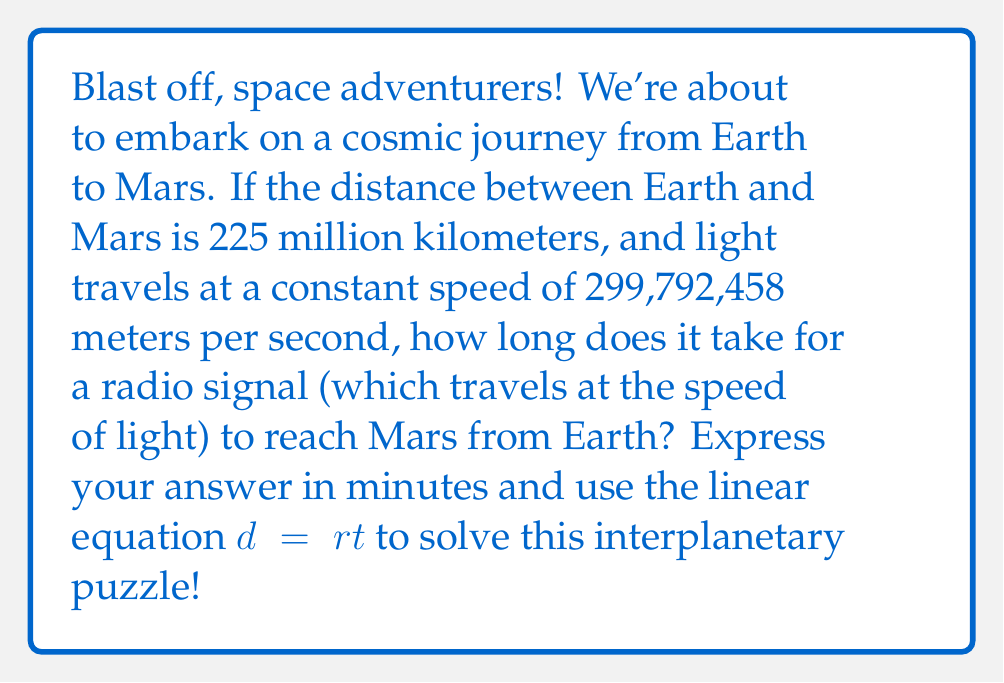Provide a solution to this math problem. Let's tackle this cosmic calculation step by step:

1) First, we need to set up our linear equation:
   $d = rt$, where
   $d$ = distance
   $r$ = rate (speed)
   $t$ = time

2) We know the distance and rate, so let's plug those in:
   225,000,000 km = 299,792,458 m/s * $t$

3) We need to convert all units to meters:
   225,000,000,000 m = 299,792,458 m/s * $t$

4) Now, let's solve for $t$:
   $$t = \frac{225,000,000,000 \text{ m}}{299,792,458 \text{ m/s}}$$

5) Let's calculate:
   $$t = 750.0000025 \text{ seconds}$$

6) The question asks for the answer in minutes, so let's convert:
   $$t = \frac{750.0000025 \text{ seconds}}{60 \text{ seconds/minute}} = 12.5000000417 \text{ minutes}$$

7) Rounding to a reasonable number of decimal places:
   $t \approx 12.5 \text{ minutes}$
Answer: 12.5 minutes 